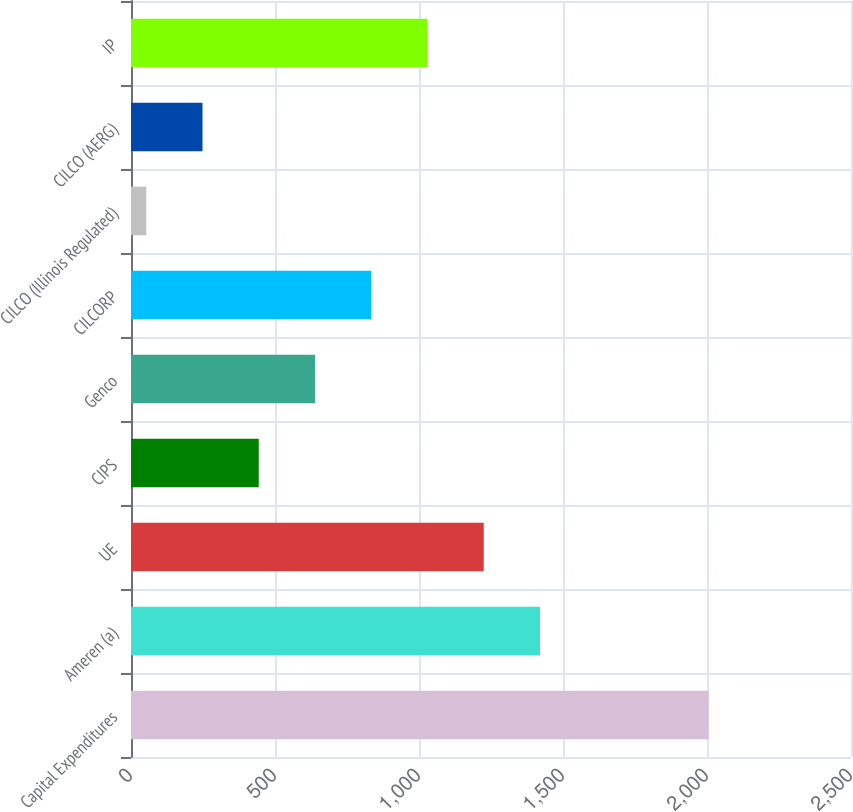<chart> <loc_0><loc_0><loc_500><loc_500><bar_chart><fcel>Capital Expenditures<fcel>Ameren (a)<fcel>UE<fcel>CIPS<fcel>Genco<fcel>CILCORP<fcel>CILCO (Illinois Regulated)<fcel>CILCO (AERG)<fcel>IP<nl><fcel>2006<fcel>1420.1<fcel>1224.8<fcel>443.6<fcel>638.9<fcel>834.2<fcel>53<fcel>248.3<fcel>1029.5<nl></chart> 